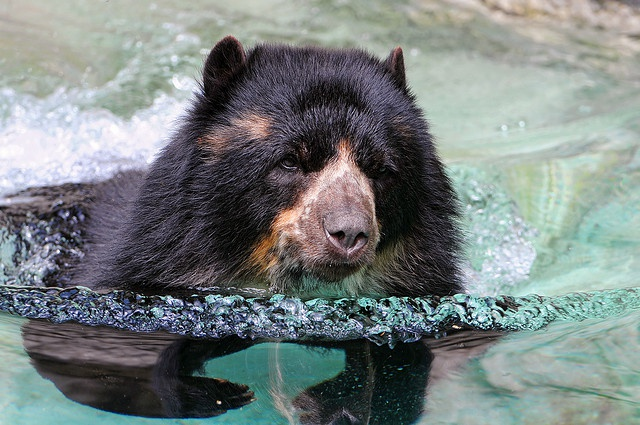Describe the objects in this image and their specific colors. I can see a bear in darkgray, black, and gray tones in this image. 